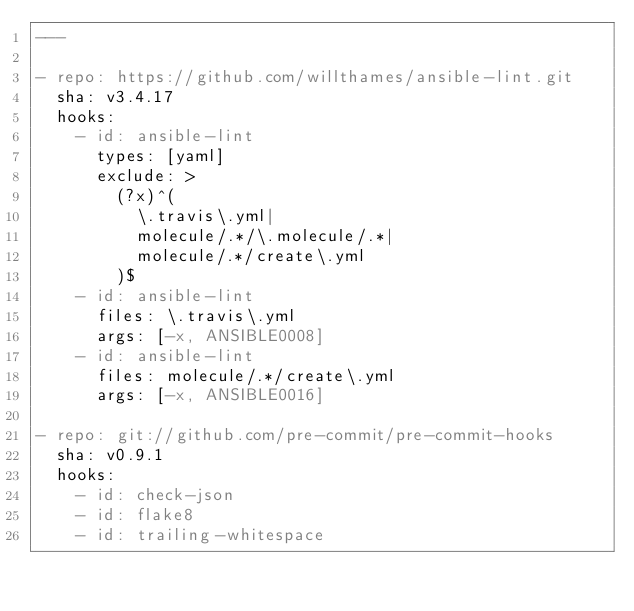<code> <loc_0><loc_0><loc_500><loc_500><_YAML_>---

- repo: https://github.com/willthames/ansible-lint.git
  sha: v3.4.17
  hooks:
    - id: ansible-lint
      types: [yaml]
      exclude: >
        (?x)^(
          \.travis\.yml|
          molecule/.*/\.molecule/.*|
          molecule/.*/create\.yml
        )$
    - id: ansible-lint
      files: \.travis\.yml
      args: [-x, ANSIBLE0008]
    - id: ansible-lint
      files: molecule/.*/create\.yml
      args: [-x, ANSIBLE0016]

- repo: git://github.com/pre-commit/pre-commit-hooks
  sha: v0.9.1
  hooks:
    - id: check-json
    - id: flake8
    - id: trailing-whitespace
</code> 